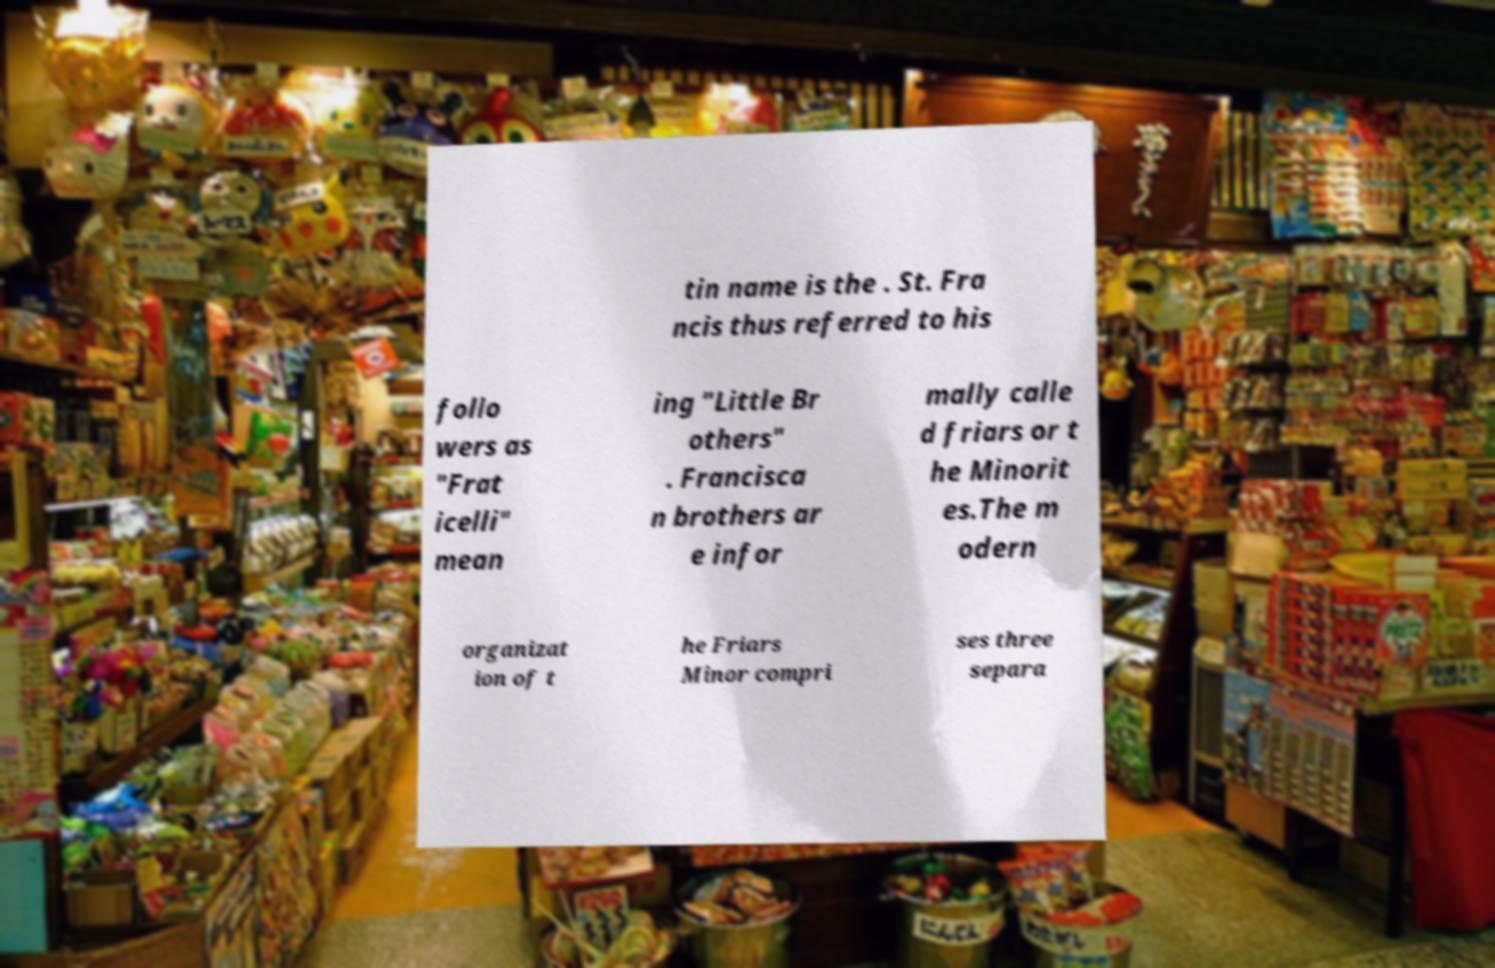Can you read and provide the text displayed in the image?This photo seems to have some interesting text. Can you extract and type it out for me? tin name is the . St. Fra ncis thus referred to his follo wers as "Frat icelli" mean ing "Little Br others" . Francisca n brothers ar e infor mally calle d friars or t he Minorit es.The m odern organizat ion of t he Friars Minor compri ses three separa 